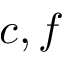Convert formula to latex. <formula><loc_0><loc_0><loc_500><loc_500>c , f</formula> 